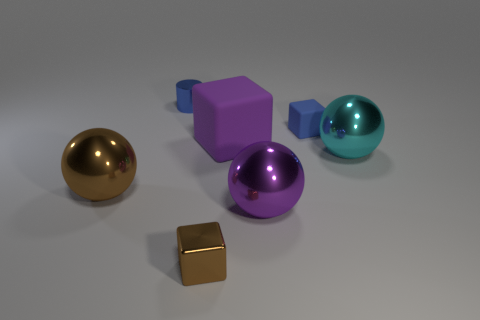Is there anything else that is the same material as the big cyan thing?
Provide a succinct answer. Yes. How many blue cylinders are the same size as the purple matte cube?
Provide a short and direct response. 0. Is the number of large cyan shiny objects that are to the left of the brown shiny ball less than the number of cyan shiny spheres that are behind the large rubber thing?
Your response must be concise. No. Is there a large purple rubber object that has the same shape as the large cyan metallic object?
Ensure brevity in your answer.  No. Is the blue matte thing the same shape as the cyan shiny object?
Give a very brief answer. No. How many small objects are cubes or cyan rubber balls?
Ensure brevity in your answer.  2. Is the number of green blocks greater than the number of small blue blocks?
Provide a succinct answer. No. What is the size of the purple thing that is made of the same material as the cyan object?
Provide a short and direct response. Large. Is the size of the purple thing in front of the big cyan metal thing the same as the block to the right of the purple matte object?
Your answer should be compact. No. How many objects are rubber blocks that are behind the big purple rubber block or small yellow rubber cylinders?
Give a very brief answer. 1. 